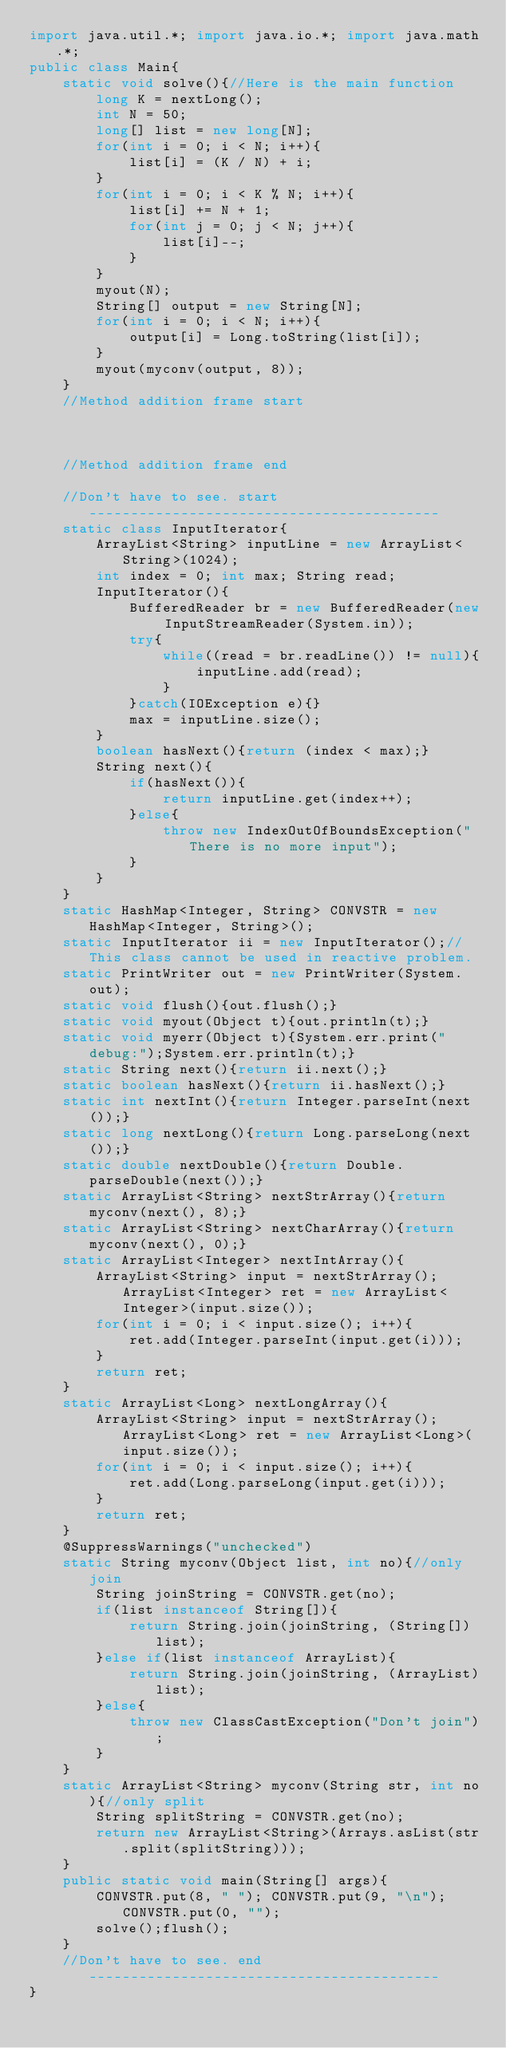Convert code to text. <code><loc_0><loc_0><loc_500><loc_500><_Java_>import java.util.*; import java.io.*; import java.math.*;
public class Main{
	static void solve(){//Here is the main function
		long K = nextLong();
		int N = 50;
		long[] list = new long[N];
		for(int i = 0; i < N; i++){
			list[i] = (K / N) + i;
		}
		for(int i = 0; i < K % N; i++){
			list[i] += N + 1;
			for(int j = 0; j < N; j++){
				list[i]--;
			}
		}
		myout(N);
		String[] output = new String[N];
		for(int i = 0; i < N; i++){
			output[i] = Long.toString(list[i]);
		}
		myout(myconv(output, 8));
	}
	//Method addition frame start



	//Method addition frame end

	//Don't have to see. start------------------------------------------
	static class InputIterator{
		ArrayList<String> inputLine = new ArrayList<String>(1024);
		int index = 0; int max; String read;
		InputIterator(){
			BufferedReader br = new BufferedReader(new InputStreamReader(System.in));
			try{
				while((read = br.readLine()) != null){
					inputLine.add(read);
				}
			}catch(IOException e){}
			max = inputLine.size();
		}
		boolean hasNext(){return (index < max);}
		String next(){
			if(hasNext()){
				return inputLine.get(index++);
			}else{
				throw new IndexOutOfBoundsException("There is no more input");
			}
		}
	}
	static HashMap<Integer, String> CONVSTR = new HashMap<Integer, String>();
	static InputIterator ii = new InputIterator();//This class cannot be used in reactive problem.
	static PrintWriter out = new PrintWriter(System.out);
	static void flush(){out.flush();}
	static void myout(Object t){out.println(t);}
	static void myerr(Object t){System.err.print("debug:");System.err.println(t);}
	static String next(){return ii.next();}
	static boolean hasNext(){return ii.hasNext();}
	static int nextInt(){return Integer.parseInt(next());}
	static long nextLong(){return Long.parseLong(next());}
	static double nextDouble(){return Double.parseDouble(next());}
	static ArrayList<String> nextStrArray(){return myconv(next(), 8);}
	static ArrayList<String> nextCharArray(){return myconv(next(), 0);}
	static ArrayList<Integer> nextIntArray(){
		ArrayList<String> input = nextStrArray(); ArrayList<Integer> ret = new ArrayList<Integer>(input.size());
		for(int i = 0; i < input.size(); i++){
			ret.add(Integer.parseInt(input.get(i)));
		}
		return ret;
	}
	static ArrayList<Long> nextLongArray(){
		ArrayList<String> input = nextStrArray(); ArrayList<Long> ret = new ArrayList<Long>(input.size());
		for(int i = 0; i < input.size(); i++){
			ret.add(Long.parseLong(input.get(i)));
		}
		return ret;
	}
	@SuppressWarnings("unchecked")
	static String myconv(Object list, int no){//only join
		String joinString = CONVSTR.get(no);
		if(list instanceof String[]){
			return String.join(joinString, (String[])list);
		}else if(list instanceof ArrayList){
			return String.join(joinString, (ArrayList)list);
		}else{
			throw new ClassCastException("Don't join");
		}
	}
	static ArrayList<String> myconv(String str, int no){//only split
		String splitString = CONVSTR.get(no);
		return new ArrayList<String>(Arrays.asList(str.split(splitString)));
	}
	public static void main(String[] args){
		CONVSTR.put(8, " "); CONVSTR.put(9, "\n"); CONVSTR.put(0, "");
		solve();flush();
	}
	//Don't have to see. end------------------------------------------
}
</code> 